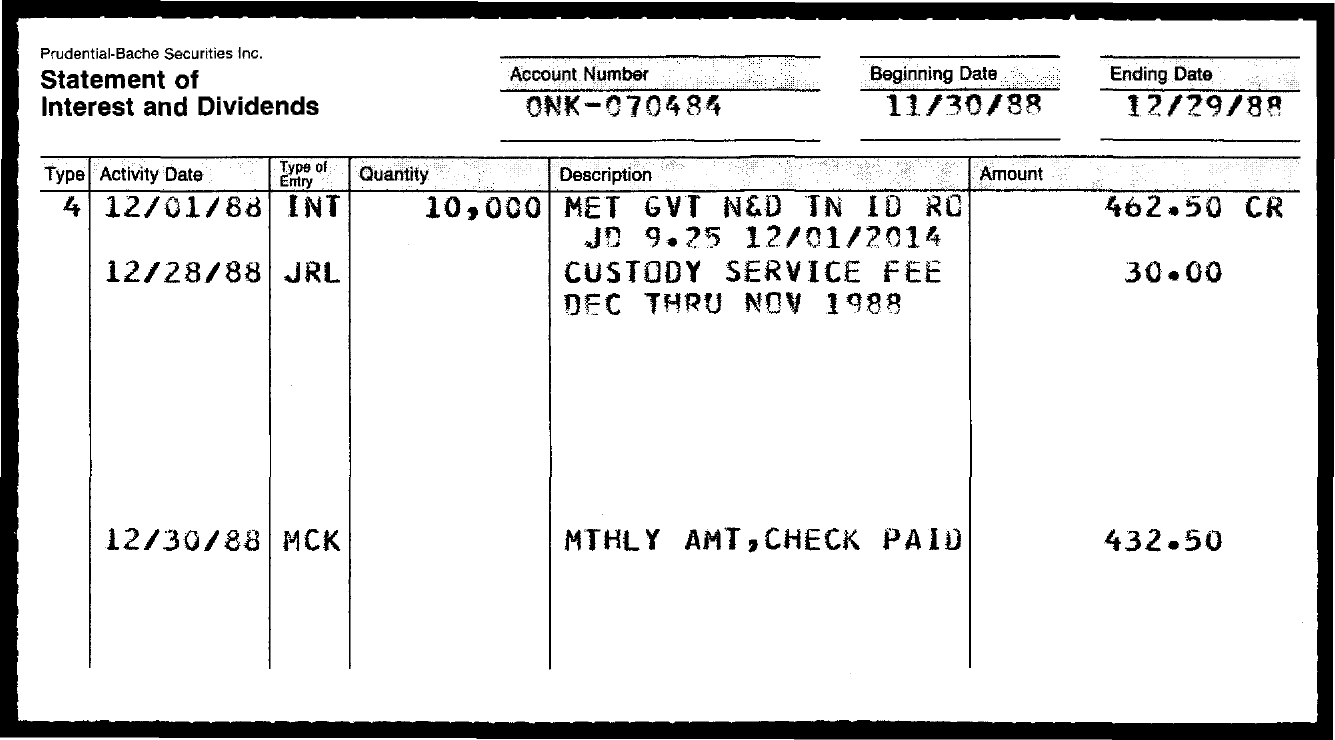What is the Account Number?
Your answer should be very brief. ONK-070484. What is the amount of entity MCK?
Offer a terse response. 432.50. 